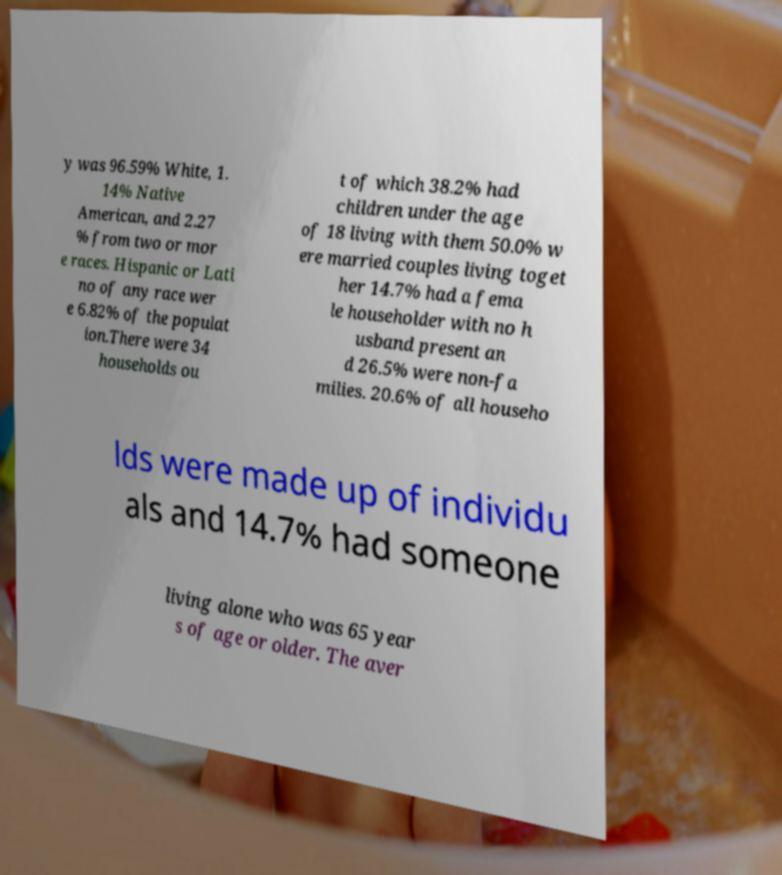I need the written content from this picture converted into text. Can you do that? y was 96.59% White, 1. 14% Native American, and 2.27 % from two or mor e races. Hispanic or Lati no of any race wer e 6.82% of the populat ion.There were 34 households ou t of which 38.2% had children under the age of 18 living with them 50.0% w ere married couples living toget her 14.7% had a fema le householder with no h usband present an d 26.5% were non-fa milies. 20.6% of all househo lds were made up of individu als and 14.7% had someone living alone who was 65 year s of age or older. The aver 